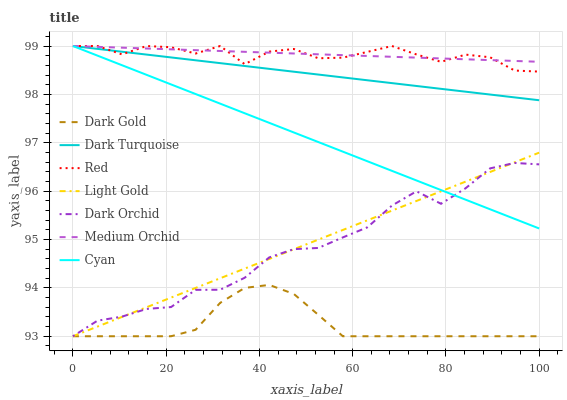Does Dark Gold have the minimum area under the curve?
Answer yes or no. Yes. Does Medium Orchid have the maximum area under the curve?
Answer yes or no. Yes. Does Dark Turquoise have the minimum area under the curve?
Answer yes or no. No. Does Dark Turquoise have the maximum area under the curve?
Answer yes or no. No. Is Dark Turquoise the smoothest?
Answer yes or no. Yes. Is Red the roughest?
Answer yes or no. Yes. Is Medium Orchid the smoothest?
Answer yes or no. No. Is Medium Orchid the roughest?
Answer yes or no. No. Does Dark Gold have the lowest value?
Answer yes or no. Yes. Does Dark Turquoise have the lowest value?
Answer yes or no. No. Does Red have the highest value?
Answer yes or no. Yes. Does Dark Orchid have the highest value?
Answer yes or no. No. Is Dark Gold less than Cyan?
Answer yes or no. Yes. Is Red greater than Dark Gold?
Answer yes or no. Yes. Does Cyan intersect Light Gold?
Answer yes or no. Yes. Is Cyan less than Light Gold?
Answer yes or no. No. Is Cyan greater than Light Gold?
Answer yes or no. No. Does Dark Gold intersect Cyan?
Answer yes or no. No. 